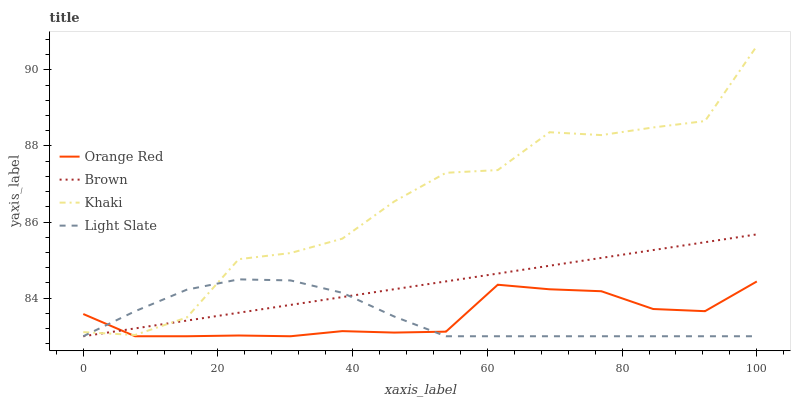Does Light Slate have the minimum area under the curve?
Answer yes or no. Yes. Does Khaki have the maximum area under the curve?
Answer yes or no. Yes. Does Brown have the minimum area under the curve?
Answer yes or no. No. Does Brown have the maximum area under the curve?
Answer yes or no. No. Is Brown the smoothest?
Answer yes or no. Yes. Is Khaki the roughest?
Answer yes or no. Yes. Is Khaki the smoothest?
Answer yes or no. No. Is Brown the roughest?
Answer yes or no. No. Does Khaki have the lowest value?
Answer yes or no. No. Does Brown have the highest value?
Answer yes or no. No. 